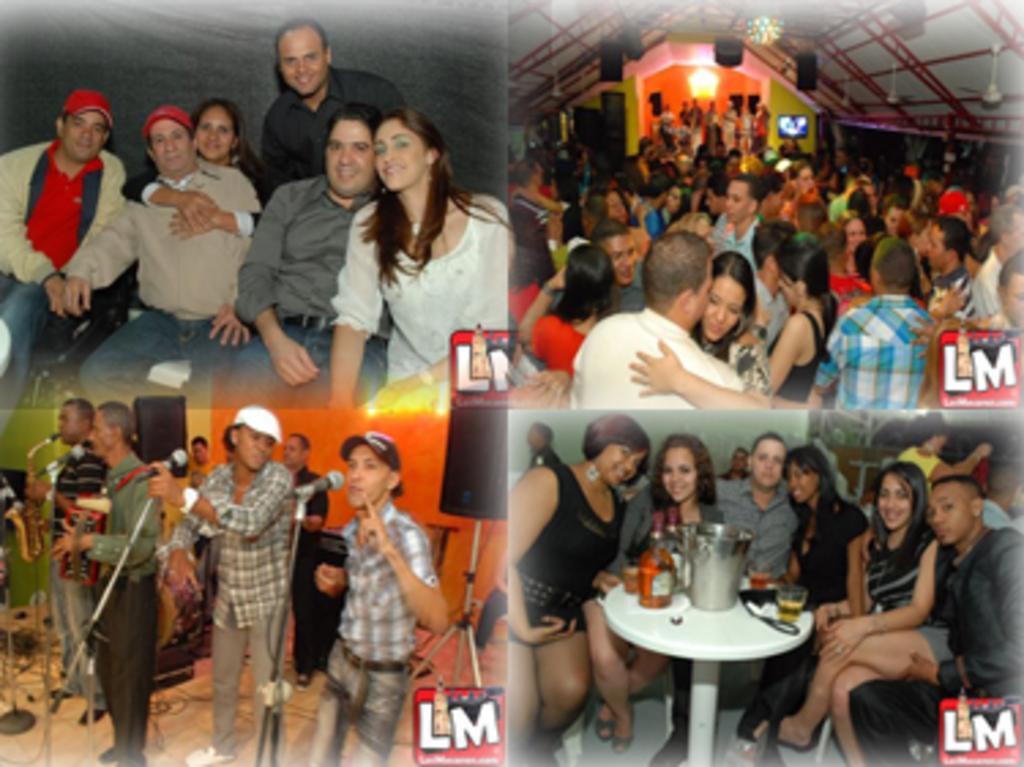In one or two sentences, can you explain what this image depicts? There are 4 images in this image. This is an edited image in the first image which is on the left side there are people sitting. In the second image on the top right corner there are people standing. In the bottom right corner image people are sitting and there is a table on the table there is a glass, bottle. In the bottom left image there are mike's. People are singing something. 